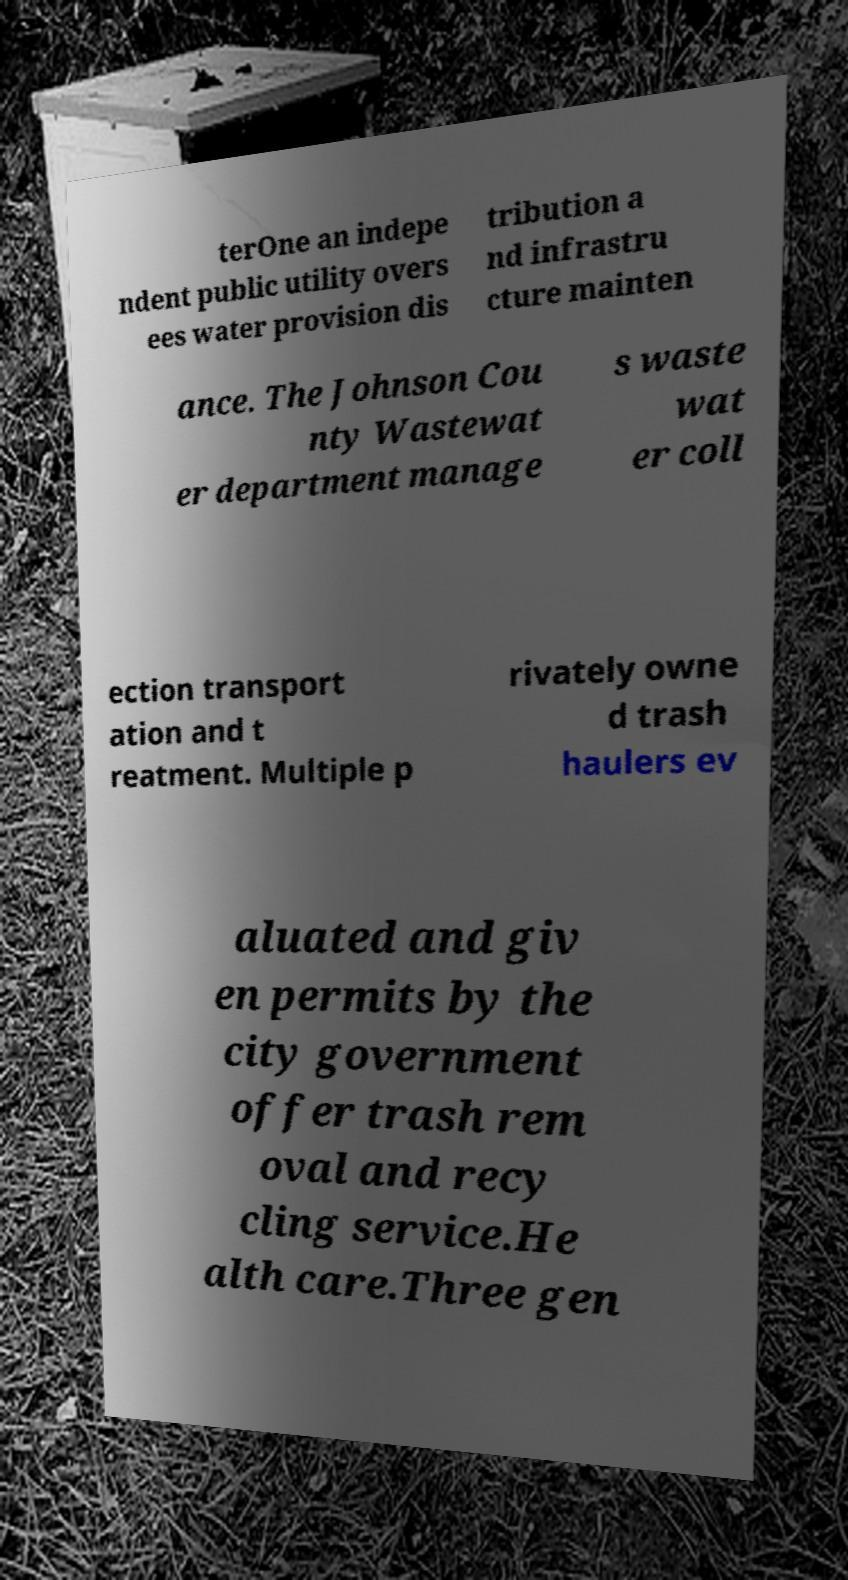Can you accurately transcribe the text from the provided image for me? terOne an indepe ndent public utility overs ees water provision dis tribution a nd infrastru cture mainten ance. The Johnson Cou nty Wastewat er department manage s waste wat er coll ection transport ation and t reatment. Multiple p rivately owne d trash haulers ev aluated and giv en permits by the city government offer trash rem oval and recy cling service.He alth care.Three gen 